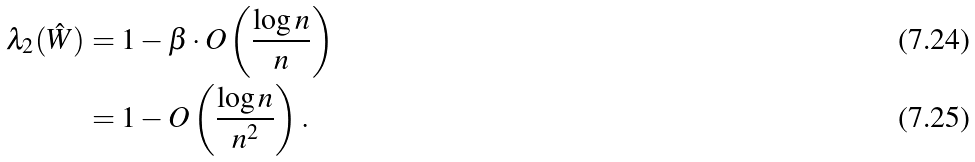Convert formula to latex. <formula><loc_0><loc_0><loc_500><loc_500>\lambda _ { 2 } ( \hat { W } ) & = 1 - \beta \cdot O \left ( \frac { \log n } { n } \right ) \\ & = 1 - O \left ( \frac { \log n } { n ^ { 2 } } \right ) .</formula> 